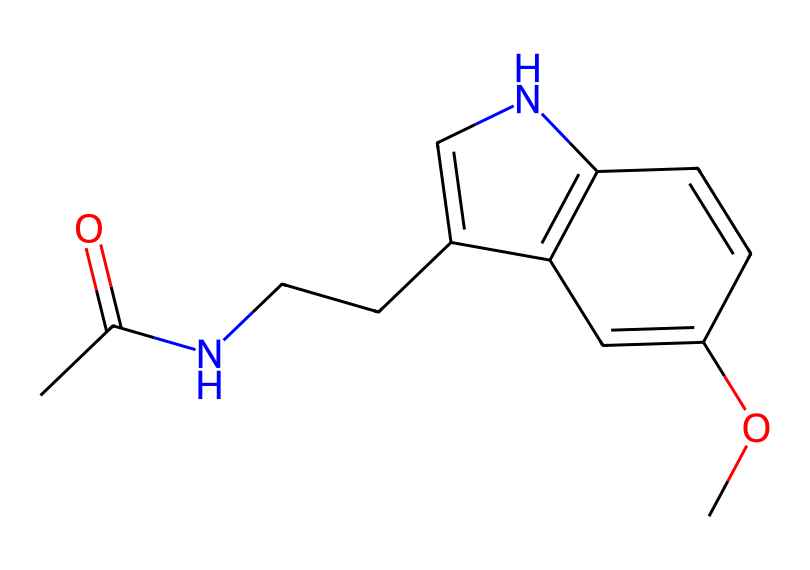What is the molecular formula of melatonin? To determine the molecular formula of melatonin, we count the individual types of atoms represented in the structure. The structure includes carbon (C), hydrogen (H), nitrogen (N), and oxygen (O) atoms. When counted, we find: 13 Carbon (C), 16 Hydrogen (H), 2 Nitrogen (N), and 1 Oxygen (O), leading to the formula C13H16N2O.
Answer: C13H16N2O How many nitrogen atoms are in melatonin? In the presented structure, the nitrogen (N) atoms can be identified by locating the atoms that are bonded to carbon and found in the aromatic rings. There are 2 instances of nitrogen in the chemical structure.
Answer: 2 What type of compound is melatonin classified as? Melatonin is classified as a hormone and also a neurotransmitter due to its action in regulating sleep cycles. Its structure indicates that it is a tryptophan derivative, which links it to the category of biologically active compounds.
Answer: hormone How many rings are present in the structure of melatonin? When analyzing the structure, we observe that there is one cyclic structure (pyrrole-like ring) due to the presence of conjugated double bonds and the arrangement of atoms. Therefore, there is a single ring in the structure of melatonin.
Answer: 1 What functional groups are present in melatonin? By examining the structure, we note different functional groups, including an amide (due to the carbonyl adjacent to nitrogen) and a methoxy group (attached to the aromatic ring). Thus, the notable functional groups are amide and methoxy.
Answer: amide, methoxy Which atom in melatonin is involved in sleep regulation? The primary active site in melatonin that is involved in sleep regulation is the nitrogen atom in the indole ring structure, which plays a crucial role in its interaction with melatonin receptors in the brain.
Answer: nitrogen 